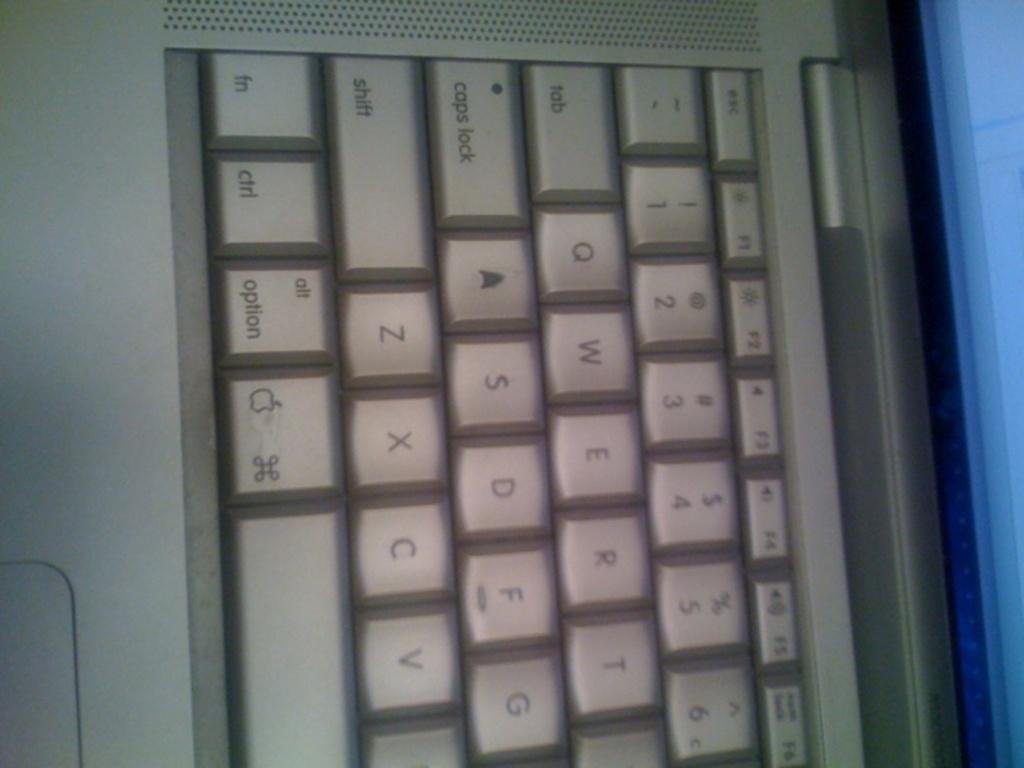What are a few letters on the keyboard?
Offer a very short reply. Asdf. What is to the left of the apple key?
Your response must be concise. Option. 